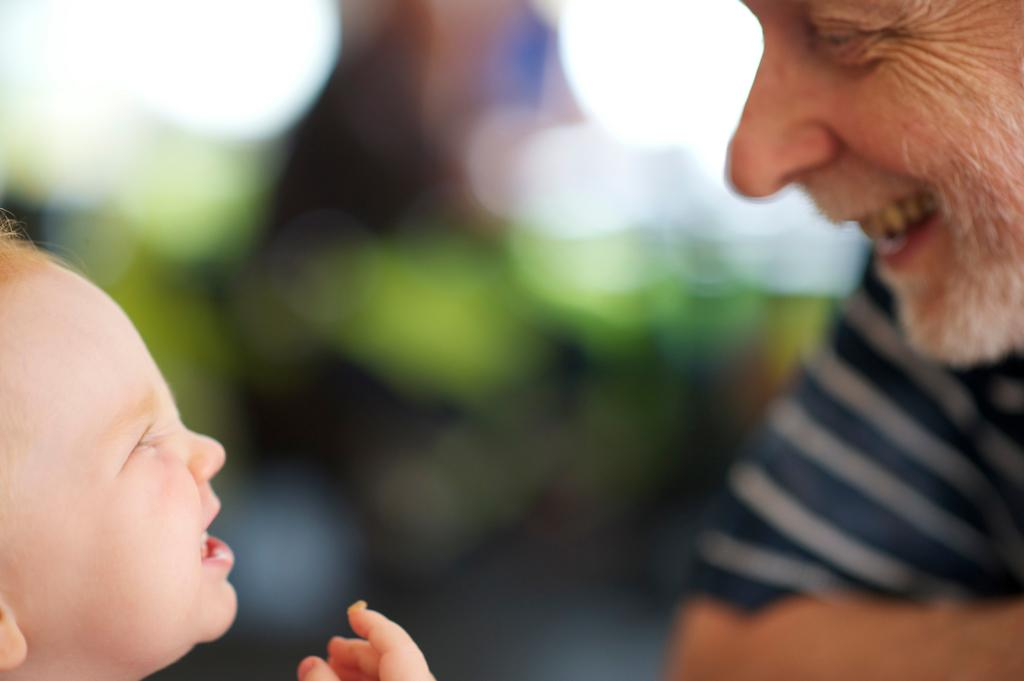Who is present in the image? There is a man and a child in the image. What expressions do the man and the child have? Both the man and the child are smiling in the image. Can you describe the background of the image? The background of the image is blurry. What type of border is visible around the child in the image? There is no border visible around the child in the image. Can you describe the swimming technique of the man in the image? There is no swimming activity depicted in the image; the man and the child are simply standing and smiling. 